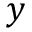Convert formula to latex. <formula><loc_0><loc_0><loc_500><loc_500>y</formula> 